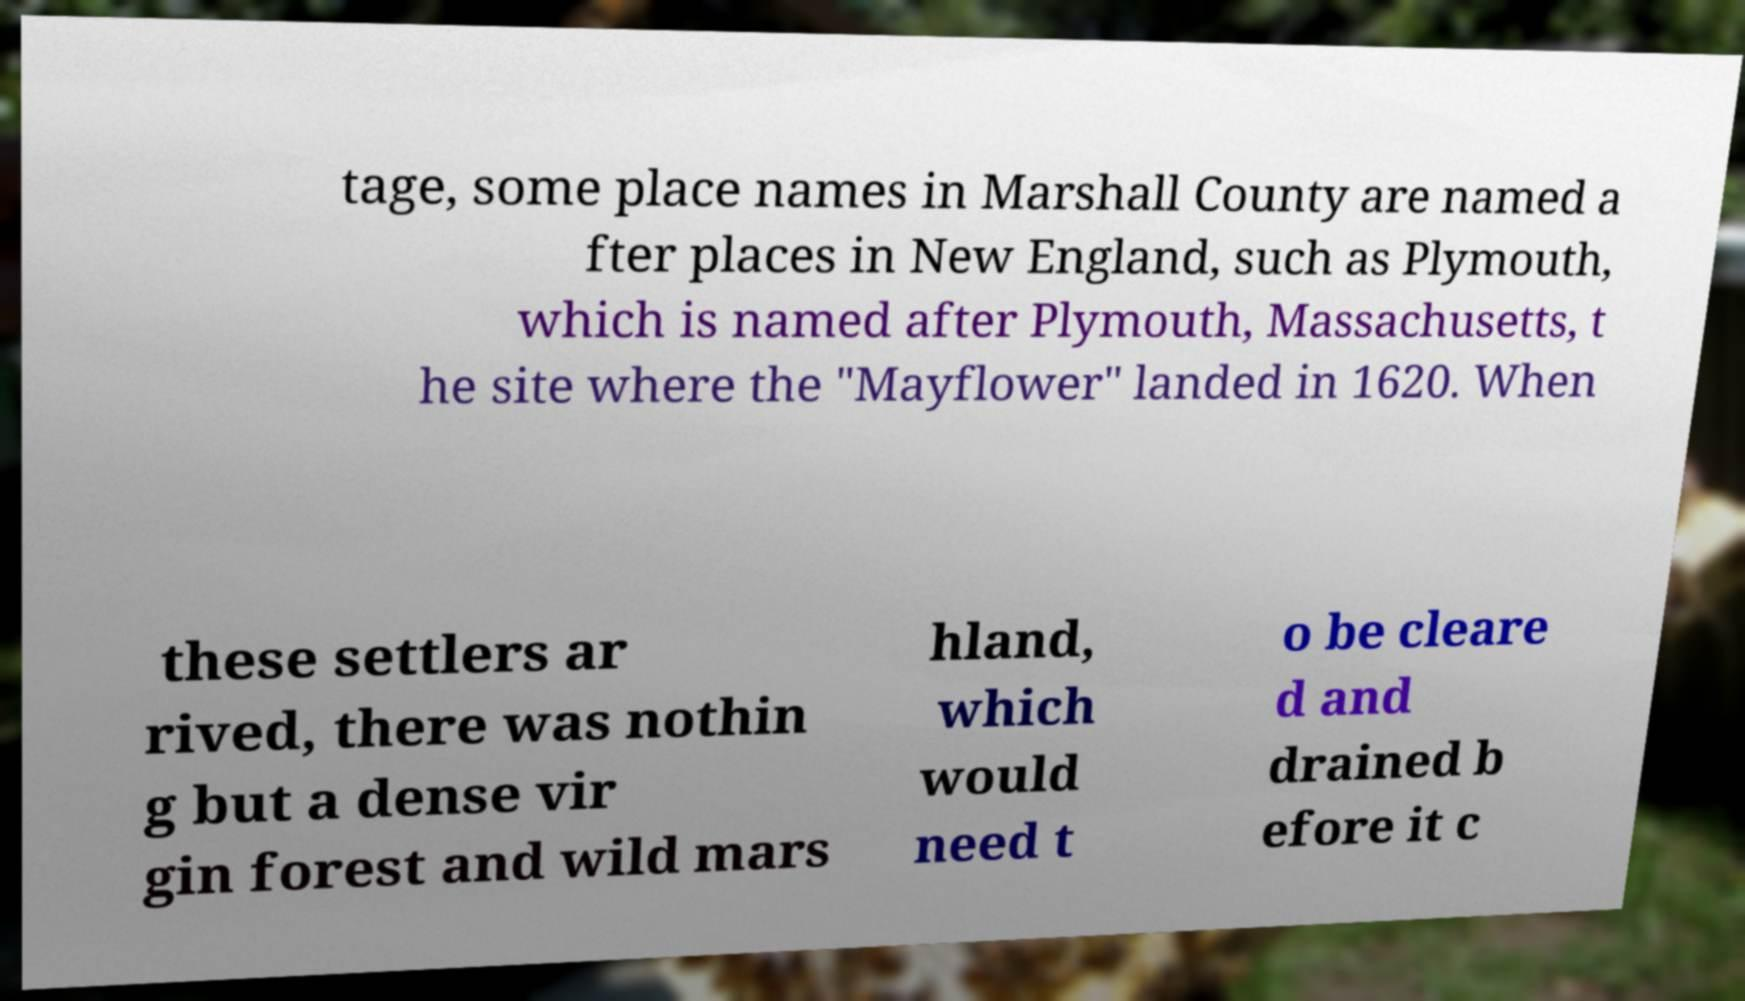There's text embedded in this image that I need extracted. Can you transcribe it verbatim? tage, some place names in Marshall County are named a fter places in New England, such as Plymouth, which is named after Plymouth, Massachusetts, t he site where the "Mayflower" landed in 1620. When these settlers ar rived, there was nothin g but a dense vir gin forest and wild mars hland, which would need t o be cleare d and drained b efore it c 